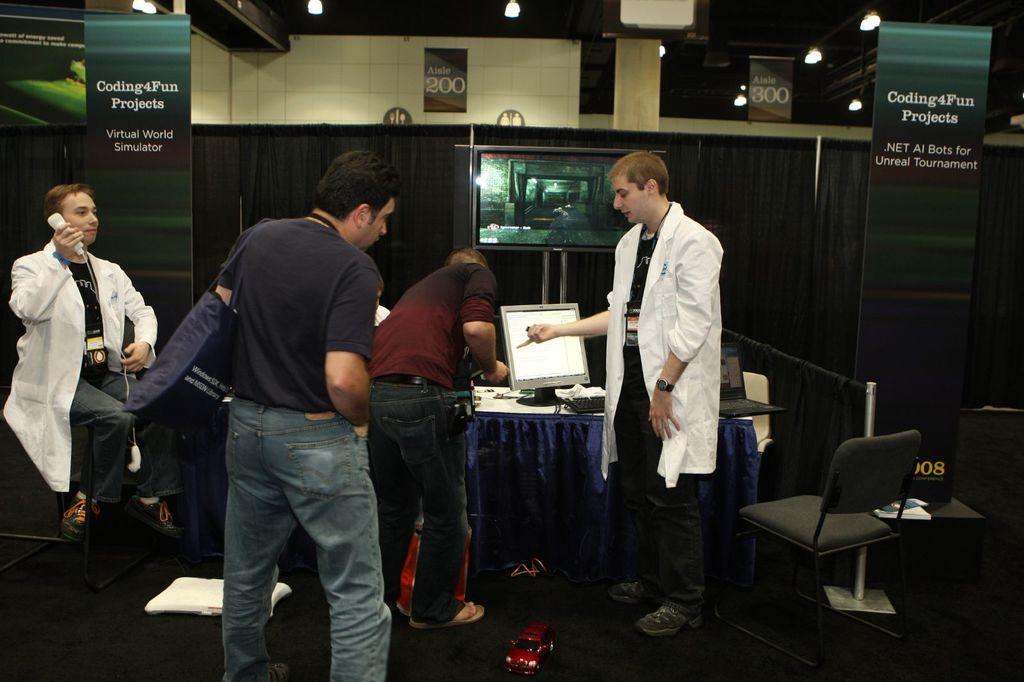Please provide a concise description of this image. In this image I can see four persons on the floor, chairs, table, PC and laptops. In the background I can see a wall, boards, curtain and lights. This image is taken in a hall. 